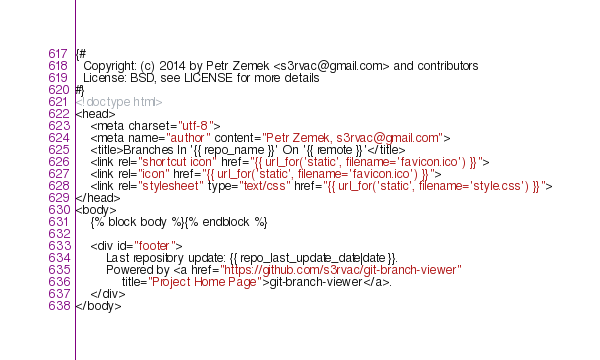<code> <loc_0><loc_0><loc_500><loc_500><_HTML_>{#
  Copyright: (c) 2014 by Petr Zemek <s3rvac@gmail.com> and contributors
  License: BSD, see LICENSE for more details
#}
<!doctype html>
<head>
	<meta charset="utf-8">
	<meta name="author" content="Petr Zemek, s3rvac@gmail.com">
	<title>Branches In '{{ repo_name }}' On '{{ remote }}'</title>
	<link rel="shortcut icon" href="{{ url_for('static', filename='favicon.ico') }}">
	<link rel="icon" href="{{ url_for('static', filename='favicon.ico') }}">
	<link rel="stylesheet" type="text/css" href="{{ url_for('static', filename='style.css') }}">
</head>
<body>
	{% block body %}{% endblock %}

	<div id="footer">
		Last repository update: {{ repo_last_update_date|date }}.
		Powered by <a href="https://github.com/s3rvac/git-branch-viewer"
			title="Project Home Page">git-branch-viewer</a>.
	</div>
</body>
</code> 